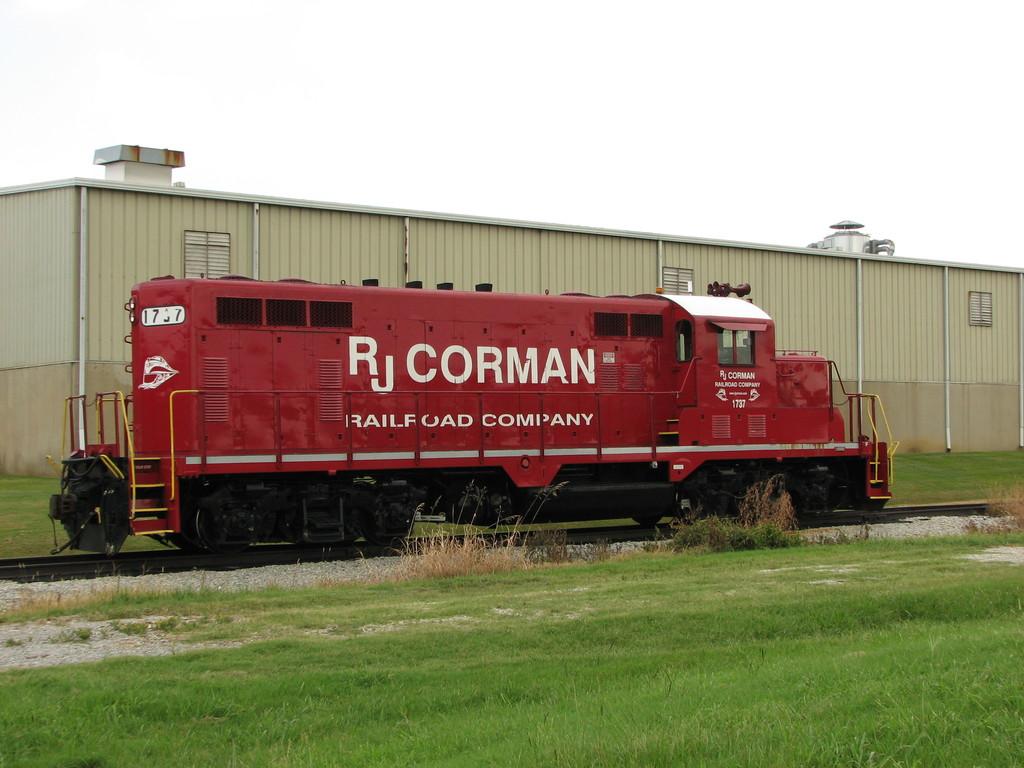What railroad company is written on this train?
Your answer should be very brief. Rj corman. What is the name of this railroad company?
Your answer should be very brief. Rj corman. 